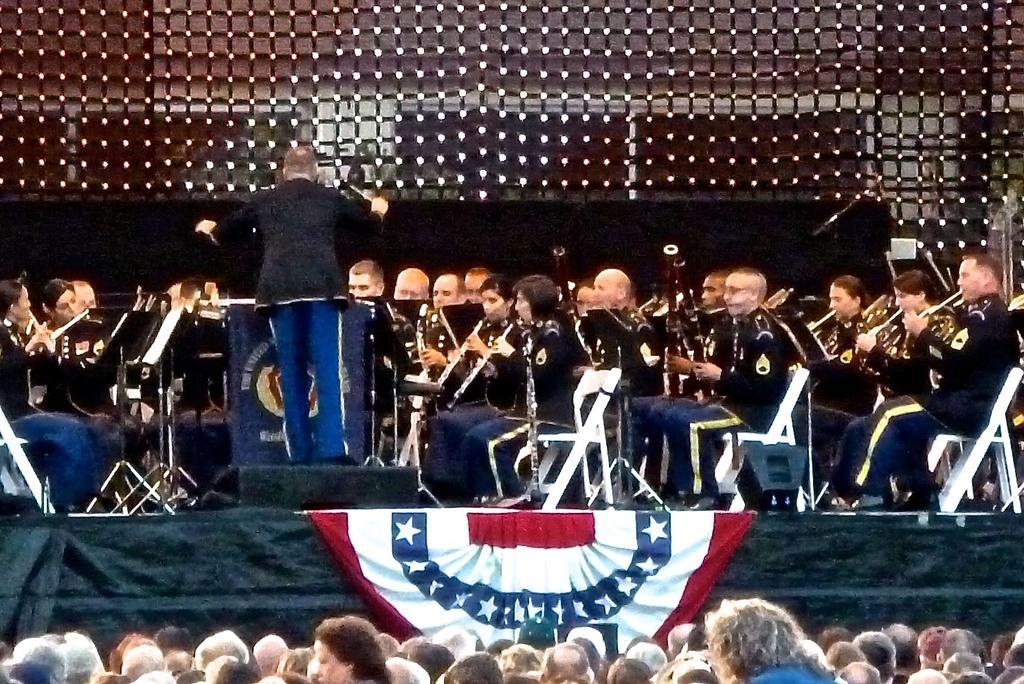Please provide a concise description of this image. In the picture I can see few audience and there is a stage in front of them which has few persons sitting and playing musical instruments and there is a person standing in middle of them is holding a stick in his hand and there is a net in the background. 